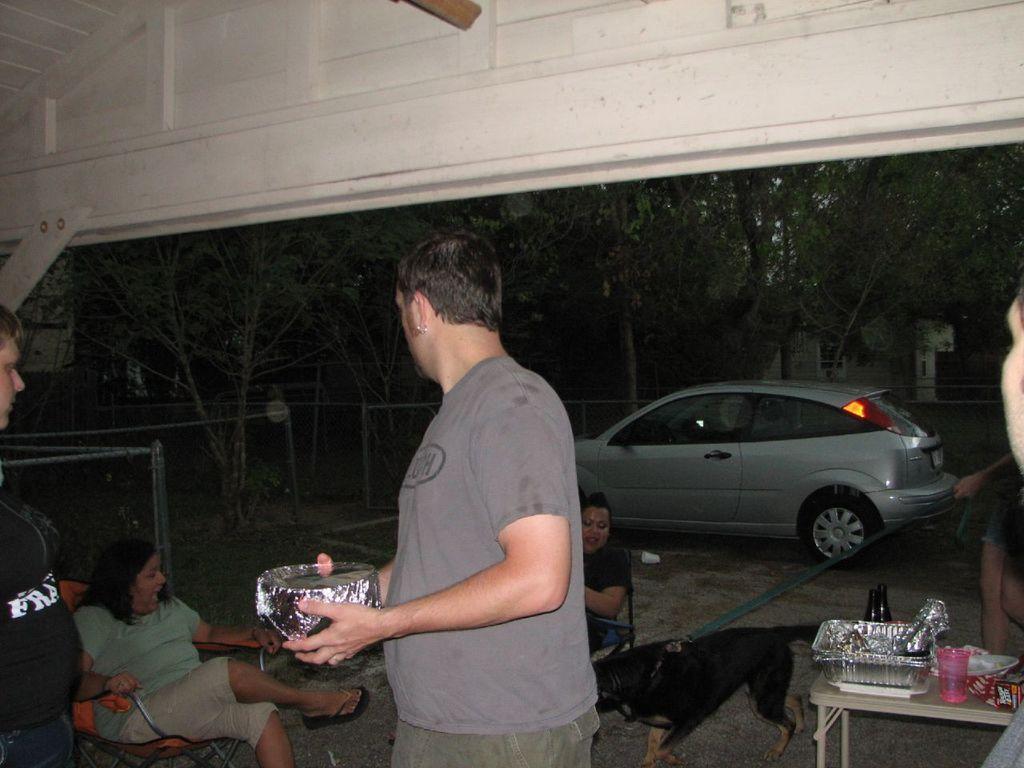In one or two sentences, can you explain what this image depicts? In the center of the image, there is a person standing and holding a bowl and there are ladies sitting on the chair and on the right, there is a table and a glass, bowl,and a tray are placed on it and we can see a dog. In the background, there are trees and a car. 